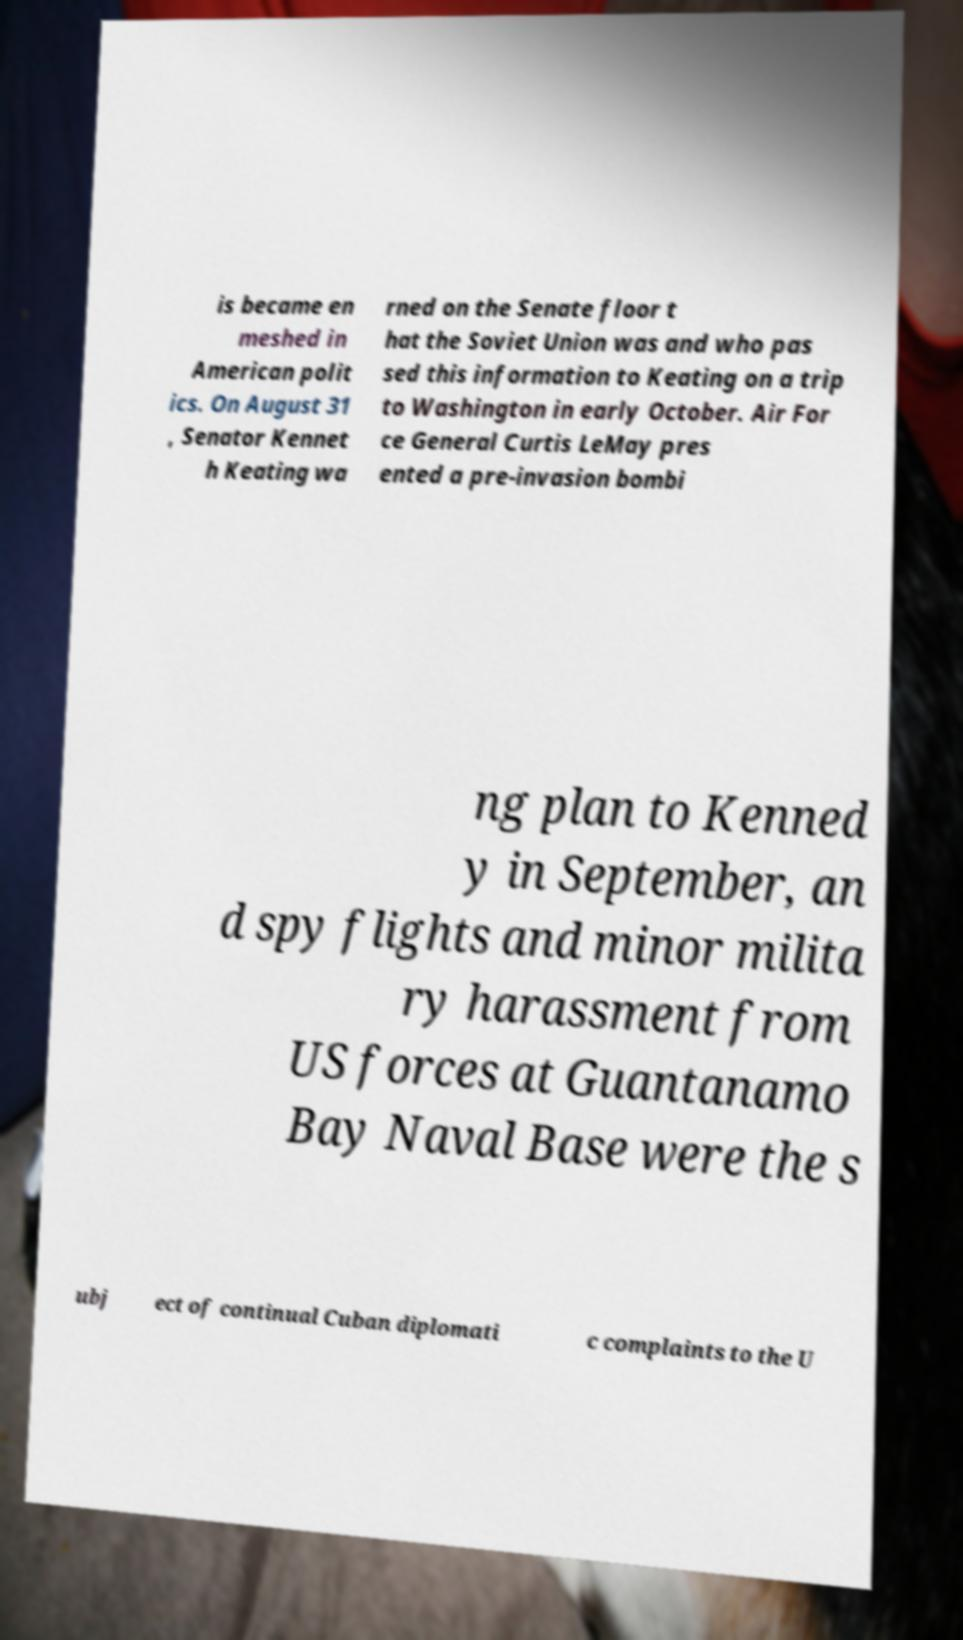For documentation purposes, I need the text within this image transcribed. Could you provide that? is became en meshed in American polit ics. On August 31 , Senator Kennet h Keating wa rned on the Senate floor t hat the Soviet Union was and who pas sed this information to Keating on a trip to Washington in early October. Air For ce General Curtis LeMay pres ented a pre-invasion bombi ng plan to Kenned y in September, an d spy flights and minor milita ry harassment from US forces at Guantanamo Bay Naval Base were the s ubj ect of continual Cuban diplomati c complaints to the U 